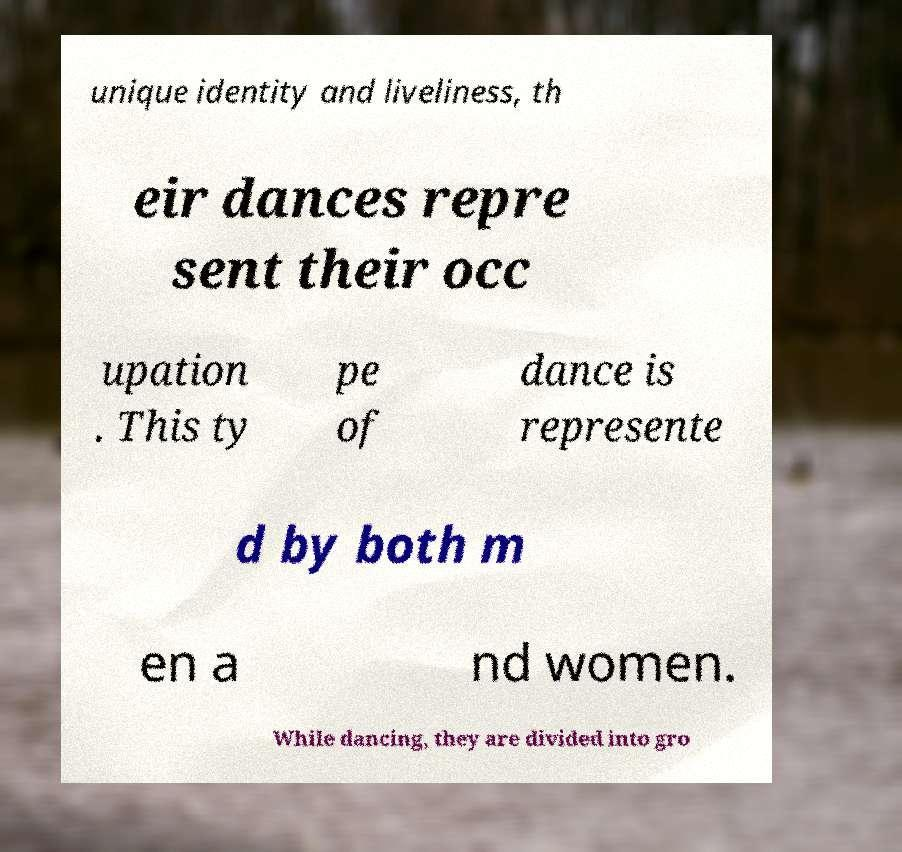Can you accurately transcribe the text from the provided image for me? unique identity and liveliness, th eir dances repre sent their occ upation . This ty pe of dance is represente d by both m en a nd women. While dancing, they are divided into gro 